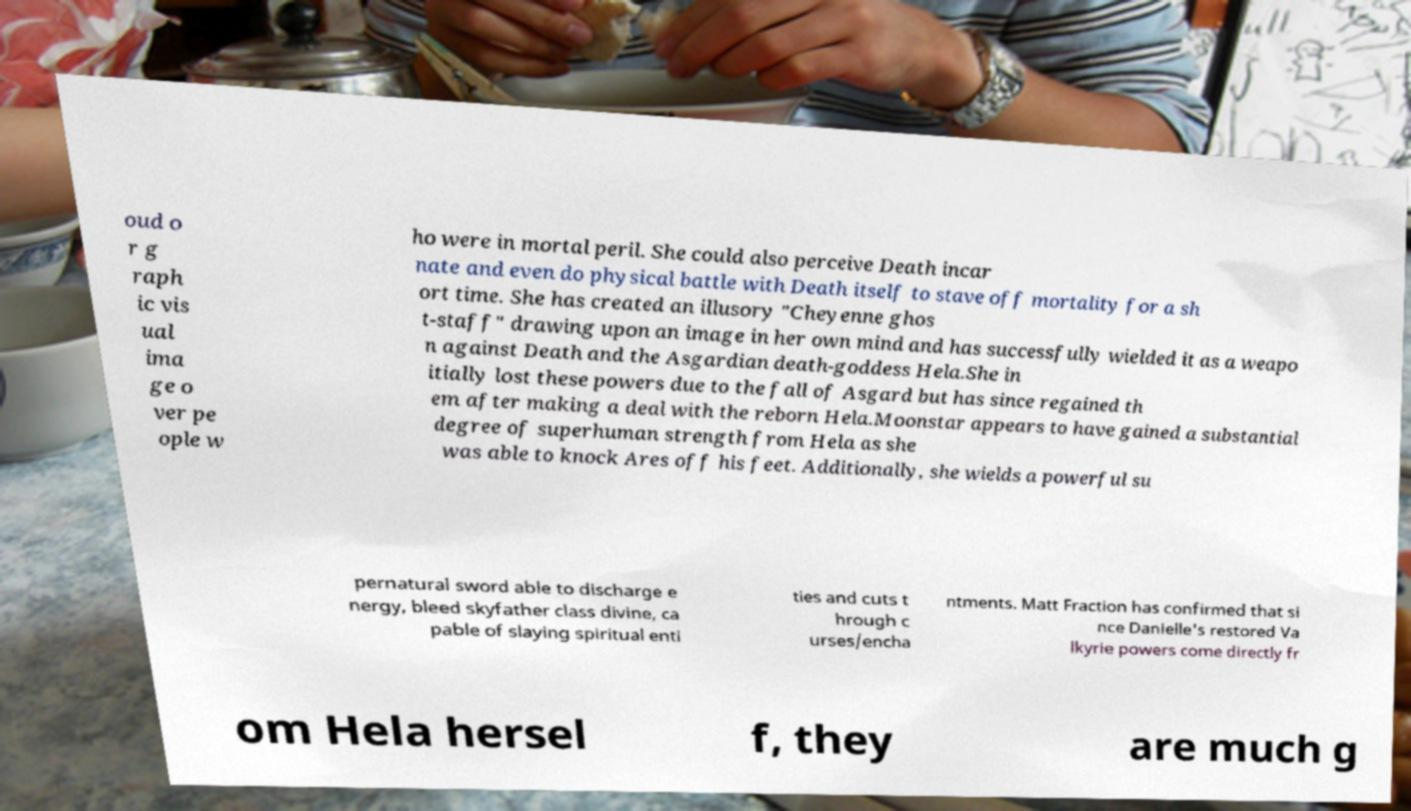What messages or text are displayed in this image? I need them in a readable, typed format. oud o r g raph ic vis ual ima ge o ver pe ople w ho were in mortal peril. She could also perceive Death incar nate and even do physical battle with Death itself to stave off mortality for a sh ort time. She has created an illusory "Cheyenne ghos t-staff" drawing upon an image in her own mind and has successfully wielded it as a weapo n against Death and the Asgardian death-goddess Hela.She in itially lost these powers due to the fall of Asgard but has since regained th em after making a deal with the reborn Hela.Moonstar appears to have gained a substantial degree of superhuman strength from Hela as she was able to knock Ares off his feet. Additionally, she wields a powerful su pernatural sword able to discharge e nergy, bleed skyfather class divine, ca pable of slaying spiritual enti ties and cuts t hrough c urses/encha ntments. Matt Fraction has confirmed that si nce Danielle's restored Va lkyrie powers come directly fr om Hela hersel f, they are much g 